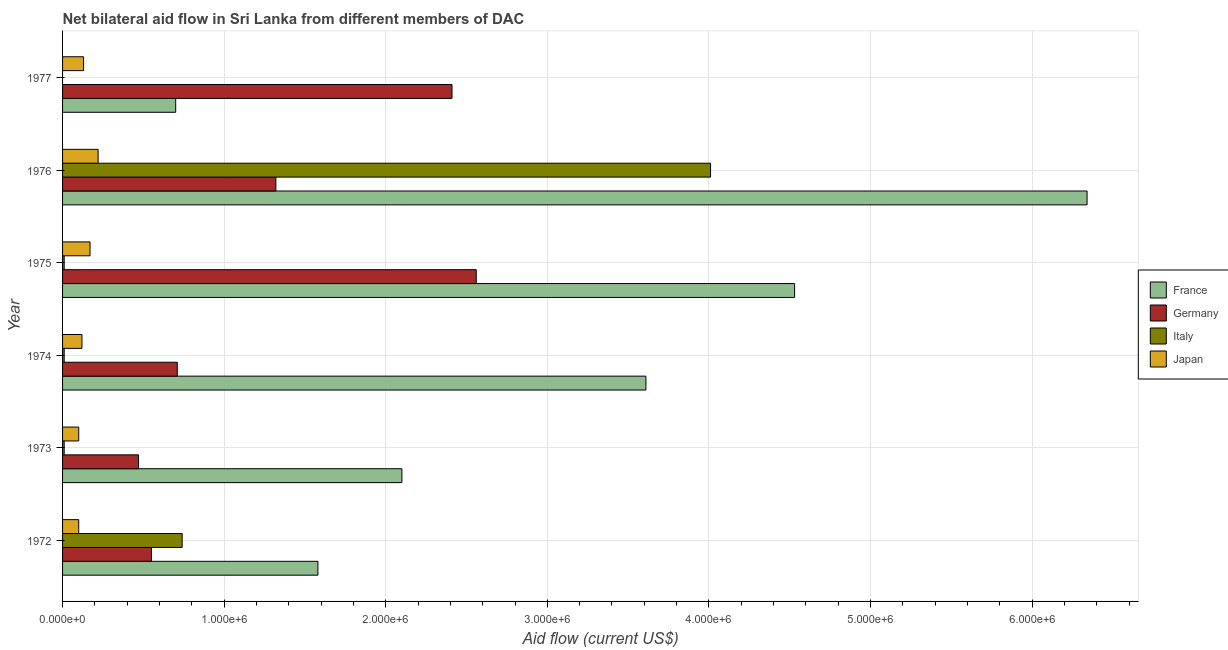How many groups of bars are there?
Your answer should be very brief. 6. Are the number of bars per tick equal to the number of legend labels?
Provide a short and direct response. No. How many bars are there on the 6th tick from the top?
Your answer should be compact. 4. How many bars are there on the 2nd tick from the bottom?
Keep it short and to the point. 4. In how many cases, is the number of bars for a given year not equal to the number of legend labels?
Give a very brief answer. 1. What is the amount of aid given by italy in 1975?
Make the answer very short. 10000. Across all years, what is the maximum amount of aid given by japan?
Provide a short and direct response. 2.20e+05. Across all years, what is the minimum amount of aid given by france?
Offer a very short reply. 7.00e+05. In which year was the amount of aid given by italy maximum?
Offer a very short reply. 1976. What is the total amount of aid given by japan in the graph?
Your response must be concise. 8.40e+05. What is the difference between the amount of aid given by france in 1972 and that in 1975?
Make the answer very short. -2.95e+06. What is the difference between the amount of aid given by italy in 1972 and the amount of aid given by germany in 1976?
Keep it short and to the point. -5.80e+05. What is the average amount of aid given by france per year?
Your response must be concise. 3.14e+06. In the year 1977, what is the difference between the amount of aid given by germany and amount of aid given by japan?
Provide a succinct answer. 2.28e+06. In how many years, is the amount of aid given by france greater than 6200000 US$?
Offer a terse response. 1. What is the ratio of the amount of aid given by japan in 1973 to that in 1976?
Ensure brevity in your answer.  0.46. What is the difference between the highest and the lowest amount of aid given by france?
Ensure brevity in your answer.  5.64e+06. Is the sum of the amount of aid given by france in 1974 and 1976 greater than the maximum amount of aid given by japan across all years?
Ensure brevity in your answer.  Yes. Is it the case that in every year, the sum of the amount of aid given by france and amount of aid given by germany is greater than the amount of aid given by italy?
Provide a succinct answer. Yes. How many bars are there?
Your answer should be compact. 23. Are all the bars in the graph horizontal?
Offer a very short reply. Yes. How many years are there in the graph?
Your answer should be very brief. 6. Are the values on the major ticks of X-axis written in scientific E-notation?
Offer a terse response. Yes. Does the graph contain any zero values?
Provide a succinct answer. Yes. Does the graph contain grids?
Make the answer very short. Yes. What is the title of the graph?
Your response must be concise. Net bilateral aid flow in Sri Lanka from different members of DAC. What is the label or title of the X-axis?
Give a very brief answer. Aid flow (current US$). What is the label or title of the Y-axis?
Your answer should be very brief. Year. What is the Aid flow (current US$) of France in 1972?
Your answer should be compact. 1.58e+06. What is the Aid flow (current US$) of Germany in 1972?
Keep it short and to the point. 5.50e+05. What is the Aid flow (current US$) in Italy in 1972?
Your response must be concise. 7.40e+05. What is the Aid flow (current US$) in France in 1973?
Your answer should be very brief. 2.10e+06. What is the Aid flow (current US$) in France in 1974?
Your answer should be compact. 3.61e+06. What is the Aid flow (current US$) in Germany in 1974?
Provide a short and direct response. 7.10e+05. What is the Aid flow (current US$) in Italy in 1974?
Your answer should be very brief. 10000. What is the Aid flow (current US$) of France in 1975?
Make the answer very short. 4.53e+06. What is the Aid flow (current US$) in Germany in 1975?
Provide a succinct answer. 2.56e+06. What is the Aid flow (current US$) in France in 1976?
Your answer should be compact. 6.34e+06. What is the Aid flow (current US$) in Germany in 1976?
Ensure brevity in your answer.  1.32e+06. What is the Aid flow (current US$) in Italy in 1976?
Offer a very short reply. 4.01e+06. What is the Aid flow (current US$) of Japan in 1976?
Your response must be concise. 2.20e+05. What is the Aid flow (current US$) of France in 1977?
Ensure brevity in your answer.  7.00e+05. What is the Aid flow (current US$) in Germany in 1977?
Make the answer very short. 2.41e+06. What is the Aid flow (current US$) of Japan in 1977?
Keep it short and to the point. 1.30e+05. Across all years, what is the maximum Aid flow (current US$) in France?
Give a very brief answer. 6.34e+06. Across all years, what is the maximum Aid flow (current US$) in Germany?
Keep it short and to the point. 2.56e+06. Across all years, what is the maximum Aid flow (current US$) in Italy?
Give a very brief answer. 4.01e+06. Across all years, what is the minimum Aid flow (current US$) in France?
Your answer should be very brief. 7.00e+05. Across all years, what is the minimum Aid flow (current US$) of Germany?
Make the answer very short. 4.70e+05. Across all years, what is the minimum Aid flow (current US$) in Japan?
Offer a very short reply. 1.00e+05. What is the total Aid flow (current US$) of France in the graph?
Provide a succinct answer. 1.89e+07. What is the total Aid flow (current US$) in Germany in the graph?
Keep it short and to the point. 8.02e+06. What is the total Aid flow (current US$) in Italy in the graph?
Offer a terse response. 4.78e+06. What is the total Aid flow (current US$) in Japan in the graph?
Your answer should be compact. 8.40e+05. What is the difference between the Aid flow (current US$) of France in 1972 and that in 1973?
Your answer should be compact. -5.20e+05. What is the difference between the Aid flow (current US$) in Italy in 1972 and that in 1973?
Provide a succinct answer. 7.30e+05. What is the difference between the Aid flow (current US$) of Japan in 1972 and that in 1973?
Offer a very short reply. 0. What is the difference between the Aid flow (current US$) in France in 1972 and that in 1974?
Give a very brief answer. -2.03e+06. What is the difference between the Aid flow (current US$) in Italy in 1972 and that in 1974?
Make the answer very short. 7.30e+05. What is the difference between the Aid flow (current US$) of Japan in 1972 and that in 1974?
Offer a terse response. -2.00e+04. What is the difference between the Aid flow (current US$) of France in 1972 and that in 1975?
Keep it short and to the point. -2.95e+06. What is the difference between the Aid flow (current US$) in Germany in 1972 and that in 1975?
Keep it short and to the point. -2.01e+06. What is the difference between the Aid flow (current US$) of Italy in 1972 and that in 1975?
Make the answer very short. 7.30e+05. What is the difference between the Aid flow (current US$) in Japan in 1972 and that in 1975?
Give a very brief answer. -7.00e+04. What is the difference between the Aid flow (current US$) in France in 1972 and that in 1976?
Give a very brief answer. -4.76e+06. What is the difference between the Aid flow (current US$) in Germany in 1972 and that in 1976?
Offer a very short reply. -7.70e+05. What is the difference between the Aid flow (current US$) in Italy in 1972 and that in 1976?
Your answer should be very brief. -3.27e+06. What is the difference between the Aid flow (current US$) in France in 1972 and that in 1977?
Offer a terse response. 8.80e+05. What is the difference between the Aid flow (current US$) in Germany in 1972 and that in 1977?
Give a very brief answer. -1.86e+06. What is the difference between the Aid flow (current US$) in Japan in 1972 and that in 1977?
Offer a terse response. -3.00e+04. What is the difference between the Aid flow (current US$) of France in 1973 and that in 1974?
Your response must be concise. -1.51e+06. What is the difference between the Aid flow (current US$) of France in 1973 and that in 1975?
Give a very brief answer. -2.43e+06. What is the difference between the Aid flow (current US$) of Germany in 1973 and that in 1975?
Your answer should be compact. -2.09e+06. What is the difference between the Aid flow (current US$) in Japan in 1973 and that in 1975?
Keep it short and to the point. -7.00e+04. What is the difference between the Aid flow (current US$) of France in 1973 and that in 1976?
Offer a terse response. -4.24e+06. What is the difference between the Aid flow (current US$) of Germany in 1973 and that in 1976?
Your answer should be very brief. -8.50e+05. What is the difference between the Aid flow (current US$) of Japan in 1973 and that in 1976?
Your answer should be very brief. -1.20e+05. What is the difference between the Aid flow (current US$) of France in 1973 and that in 1977?
Provide a short and direct response. 1.40e+06. What is the difference between the Aid flow (current US$) in Germany in 1973 and that in 1977?
Your answer should be compact. -1.94e+06. What is the difference between the Aid flow (current US$) of Japan in 1973 and that in 1977?
Make the answer very short. -3.00e+04. What is the difference between the Aid flow (current US$) in France in 1974 and that in 1975?
Give a very brief answer. -9.20e+05. What is the difference between the Aid flow (current US$) in Germany in 1974 and that in 1975?
Ensure brevity in your answer.  -1.85e+06. What is the difference between the Aid flow (current US$) in Italy in 1974 and that in 1975?
Provide a succinct answer. 0. What is the difference between the Aid flow (current US$) of Japan in 1974 and that in 1975?
Provide a short and direct response. -5.00e+04. What is the difference between the Aid flow (current US$) in France in 1974 and that in 1976?
Provide a succinct answer. -2.73e+06. What is the difference between the Aid flow (current US$) of Germany in 1974 and that in 1976?
Your answer should be very brief. -6.10e+05. What is the difference between the Aid flow (current US$) in Italy in 1974 and that in 1976?
Your response must be concise. -4.00e+06. What is the difference between the Aid flow (current US$) of Japan in 1974 and that in 1976?
Keep it short and to the point. -1.00e+05. What is the difference between the Aid flow (current US$) of France in 1974 and that in 1977?
Provide a succinct answer. 2.91e+06. What is the difference between the Aid flow (current US$) in Germany in 1974 and that in 1977?
Your response must be concise. -1.70e+06. What is the difference between the Aid flow (current US$) in France in 1975 and that in 1976?
Provide a succinct answer. -1.81e+06. What is the difference between the Aid flow (current US$) in Germany in 1975 and that in 1976?
Your answer should be compact. 1.24e+06. What is the difference between the Aid flow (current US$) of Japan in 1975 and that in 1976?
Offer a very short reply. -5.00e+04. What is the difference between the Aid flow (current US$) of France in 1975 and that in 1977?
Provide a succinct answer. 3.83e+06. What is the difference between the Aid flow (current US$) in Germany in 1975 and that in 1977?
Your response must be concise. 1.50e+05. What is the difference between the Aid flow (current US$) of Japan in 1975 and that in 1977?
Your answer should be compact. 4.00e+04. What is the difference between the Aid flow (current US$) in France in 1976 and that in 1977?
Ensure brevity in your answer.  5.64e+06. What is the difference between the Aid flow (current US$) of Germany in 1976 and that in 1977?
Your answer should be very brief. -1.09e+06. What is the difference between the Aid flow (current US$) in France in 1972 and the Aid flow (current US$) in Germany in 1973?
Your answer should be very brief. 1.11e+06. What is the difference between the Aid flow (current US$) in France in 1972 and the Aid flow (current US$) in Italy in 1973?
Your response must be concise. 1.57e+06. What is the difference between the Aid flow (current US$) of France in 1972 and the Aid flow (current US$) of Japan in 1973?
Provide a short and direct response. 1.48e+06. What is the difference between the Aid flow (current US$) in Germany in 1972 and the Aid flow (current US$) in Italy in 1973?
Provide a short and direct response. 5.40e+05. What is the difference between the Aid flow (current US$) in Germany in 1972 and the Aid flow (current US$) in Japan in 1973?
Your response must be concise. 4.50e+05. What is the difference between the Aid flow (current US$) in Italy in 1972 and the Aid flow (current US$) in Japan in 1973?
Make the answer very short. 6.40e+05. What is the difference between the Aid flow (current US$) of France in 1972 and the Aid flow (current US$) of Germany in 1974?
Give a very brief answer. 8.70e+05. What is the difference between the Aid flow (current US$) in France in 1972 and the Aid flow (current US$) in Italy in 1974?
Provide a succinct answer. 1.57e+06. What is the difference between the Aid flow (current US$) of France in 1972 and the Aid flow (current US$) of Japan in 1974?
Keep it short and to the point. 1.46e+06. What is the difference between the Aid flow (current US$) of Germany in 1972 and the Aid flow (current US$) of Italy in 1974?
Offer a very short reply. 5.40e+05. What is the difference between the Aid flow (current US$) of Germany in 1972 and the Aid flow (current US$) of Japan in 1974?
Keep it short and to the point. 4.30e+05. What is the difference between the Aid flow (current US$) of Italy in 1972 and the Aid flow (current US$) of Japan in 1974?
Offer a very short reply. 6.20e+05. What is the difference between the Aid flow (current US$) in France in 1972 and the Aid flow (current US$) in Germany in 1975?
Ensure brevity in your answer.  -9.80e+05. What is the difference between the Aid flow (current US$) of France in 1972 and the Aid flow (current US$) of Italy in 1975?
Your response must be concise. 1.57e+06. What is the difference between the Aid flow (current US$) in France in 1972 and the Aid flow (current US$) in Japan in 1975?
Your response must be concise. 1.41e+06. What is the difference between the Aid flow (current US$) of Germany in 1972 and the Aid flow (current US$) of Italy in 1975?
Offer a very short reply. 5.40e+05. What is the difference between the Aid flow (current US$) of Germany in 1972 and the Aid flow (current US$) of Japan in 1975?
Offer a very short reply. 3.80e+05. What is the difference between the Aid flow (current US$) in Italy in 1972 and the Aid flow (current US$) in Japan in 1975?
Give a very brief answer. 5.70e+05. What is the difference between the Aid flow (current US$) in France in 1972 and the Aid flow (current US$) in Italy in 1976?
Offer a very short reply. -2.43e+06. What is the difference between the Aid flow (current US$) in France in 1972 and the Aid flow (current US$) in Japan in 1976?
Offer a terse response. 1.36e+06. What is the difference between the Aid flow (current US$) in Germany in 1972 and the Aid flow (current US$) in Italy in 1976?
Your answer should be very brief. -3.46e+06. What is the difference between the Aid flow (current US$) of Germany in 1972 and the Aid flow (current US$) of Japan in 1976?
Ensure brevity in your answer.  3.30e+05. What is the difference between the Aid flow (current US$) of Italy in 1972 and the Aid flow (current US$) of Japan in 1976?
Offer a very short reply. 5.20e+05. What is the difference between the Aid flow (current US$) in France in 1972 and the Aid flow (current US$) in Germany in 1977?
Your answer should be very brief. -8.30e+05. What is the difference between the Aid flow (current US$) of France in 1972 and the Aid flow (current US$) of Japan in 1977?
Make the answer very short. 1.45e+06. What is the difference between the Aid flow (current US$) in Germany in 1972 and the Aid flow (current US$) in Japan in 1977?
Your response must be concise. 4.20e+05. What is the difference between the Aid flow (current US$) of Italy in 1972 and the Aid flow (current US$) of Japan in 1977?
Your response must be concise. 6.10e+05. What is the difference between the Aid flow (current US$) in France in 1973 and the Aid flow (current US$) in Germany in 1974?
Make the answer very short. 1.39e+06. What is the difference between the Aid flow (current US$) in France in 1973 and the Aid flow (current US$) in Italy in 1974?
Ensure brevity in your answer.  2.09e+06. What is the difference between the Aid flow (current US$) of France in 1973 and the Aid flow (current US$) of Japan in 1974?
Provide a short and direct response. 1.98e+06. What is the difference between the Aid flow (current US$) in Germany in 1973 and the Aid flow (current US$) in Italy in 1974?
Offer a terse response. 4.60e+05. What is the difference between the Aid flow (current US$) of France in 1973 and the Aid flow (current US$) of Germany in 1975?
Offer a very short reply. -4.60e+05. What is the difference between the Aid flow (current US$) in France in 1973 and the Aid flow (current US$) in Italy in 1975?
Your answer should be compact. 2.09e+06. What is the difference between the Aid flow (current US$) in France in 1973 and the Aid flow (current US$) in Japan in 1975?
Make the answer very short. 1.93e+06. What is the difference between the Aid flow (current US$) in Germany in 1973 and the Aid flow (current US$) in Japan in 1975?
Keep it short and to the point. 3.00e+05. What is the difference between the Aid flow (current US$) in Italy in 1973 and the Aid flow (current US$) in Japan in 1975?
Your answer should be very brief. -1.60e+05. What is the difference between the Aid flow (current US$) of France in 1973 and the Aid flow (current US$) of Germany in 1976?
Give a very brief answer. 7.80e+05. What is the difference between the Aid flow (current US$) of France in 1973 and the Aid flow (current US$) of Italy in 1976?
Offer a terse response. -1.91e+06. What is the difference between the Aid flow (current US$) in France in 1973 and the Aid flow (current US$) in Japan in 1976?
Your answer should be very brief. 1.88e+06. What is the difference between the Aid flow (current US$) in Germany in 1973 and the Aid flow (current US$) in Italy in 1976?
Provide a succinct answer. -3.54e+06. What is the difference between the Aid flow (current US$) of Italy in 1973 and the Aid flow (current US$) of Japan in 1976?
Keep it short and to the point. -2.10e+05. What is the difference between the Aid flow (current US$) of France in 1973 and the Aid flow (current US$) of Germany in 1977?
Offer a terse response. -3.10e+05. What is the difference between the Aid flow (current US$) of France in 1973 and the Aid flow (current US$) of Japan in 1977?
Offer a very short reply. 1.97e+06. What is the difference between the Aid flow (current US$) in France in 1974 and the Aid flow (current US$) in Germany in 1975?
Provide a succinct answer. 1.05e+06. What is the difference between the Aid flow (current US$) of France in 1974 and the Aid flow (current US$) of Italy in 1975?
Provide a short and direct response. 3.60e+06. What is the difference between the Aid flow (current US$) of France in 1974 and the Aid flow (current US$) of Japan in 1975?
Provide a succinct answer. 3.44e+06. What is the difference between the Aid flow (current US$) in Germany in 1974 and the Aid flow (current US$) in Japan in 1975?
Give a very brief answer. 5.40e+05. What is the difference between the Aid flow (current US$) of France in 1974 and the Aid flow (current US$) of Germany in 1976?
Ensure brevity in your answer.  2.29e+06. What is the difference between the Aid flow (current US$) in France in 1974 and the Aid flow (current US$) in Italy in 1976?
Ensure brevity in your answer.  -4.00e+05. What is the difference between the Aid flow (current US$) in France in 1974 and the Aid flow (current US$) in Japan in 1976?
Keep it short and to the point. 3.39e+06. What is the difference between the Aid flow (current US$) in Germany in 1974 and the Aid flow (current US$) in Italy in 1976?
Your answer should be compact. -3.30e+06. What is the difference between the Aid flow (current US$) of Germany in 1974 and the Aid flow (current US$) of Japan in 1976?
Make the answer very short. 4.90e+05. What is the difference between the Aid flow (current US$) of France in 1974 and the Aid flow (current US$) of Germany in 1977?
Your answer should be very brief. 1.20e+06. What is the difference between the Aid flow (current US$) in France in 1974 and the Aid flow (current US$) in Japan in 1977?
Ensure brevity in your answer.  3.48e+06. What is the difference between the Aid flow (current US$) of Germany in 1974 and the Aid flow (current US$) of Japan in 1977?
Your answer should be compact. 5.80e+05. What is the difference between the Aid flow (current US$) of Italy in 1974 and the Aid flow (current US$) of Japan in 1977?
Keep it short and to the point. -1.20e+05. What is the difference between the Aid flow (current US$) in France in 1975 and the Aid flow (current US$) in Germany in 1976?
Your answer should be compact. 3.21e+06. What is the difference between the Aid flow (current US$) of France in 1975 and the Aid flow (current US$) of Italy in 1976?
Offer a very short reply. 5.20e+05. What is the difference between the Aid flow (current US$) in France in 1975 and the Aid flow (current US$) in Japan in 1976?
Make the answer very short. 4.31e+06. What is the difference between the Aid flow (current US$) of Germany in 1975 and the Aid flow (current US$) of Italy in 1976?
Your response must be concise. -1.45e+06. What is the difference between the Aid flow (current US$) in Germany in 1975 and the Aid flow (current US$) in Japan in 1976?
Provide a short and direct response. 2.34e+06. What is the difference between the Aid flow (current US$) in Italy in 1975 and the Aid flow (current US$) in Japan in 1976?
Make the answer very short. -2.10e+05. What is the difference between the Aid flow (current US$) in France in 1975 and the Aid flow (current US$) in Germany in 1977?
Keep it short and to the point. 2.12e+06. What is the difference between the Aid flow (current US$) in France in 1975 and the Aid flow (current US$) in Japan in 1977?
Provide a short and direct response. 4.40e+06. What is the difference between the Aid flow (current US$) in Germany in 1975 and the Aid flow (current US$) in Japan in 1977?
Offer a terse response. 2.43e+06. What is the difference between the Aid flow (current US$) in Italy in 1975 and the Aid flow (current US$) in Japan in 1977?
Offer a terse response. -1.20e+05. What is the difference between the Aid flow (current US$) in France in 1976 and the Aid flow (current US$) in Germany in 1977?
Your answer should be very brief. 3.93e+06. What is the difference between the Aid flow (current US$) in France in 1976 and the Aid flow (current US$) in Japan in 1977?
Offer a terse response. 6.21e+06. What is the difference between the Aid flow (current US$) in Germany in 1976 and the Aid flow (current US$) in Japan in 1977?
Give a very brief answer. 1.19e+06. What is the difference between the Aid flow (current US$) of Italy in 1976 and the Aid flow (current US$) of Japan in 1977?
Your response must be concise. 3.88e+06. What is the average Aid flow (current US$) of France per year?
Provide a short and direct response. 3.14e+06. What is the average Aid flow (current US$) in Germany per year?
Offer a terse response. 1.34e+06. What is the average Aid flow (current US$) of Italy per year?
Provide a succinct answer. 7.97e+05. In the year 1972, what is the difference between the Aid flow (current US$) of France and Aid flow (current US$) of Germany?
Ensure brevity in your answer.  1.03e+06. In the year 1972, what is the difference between the Aid flow (current US$) of France and Aid flow (current US$) of Italy?
Provide a succinct answer. 8.40e+05. In the year 1972, what is the difference between the Aid flow (current US$) in France and Aid flow (current US$) in Japan?
Provide a succinct answer. 1.48e+06. In the year 1972, what is the difference between the Aid flow (current US$) in Germany and Aid flow (current US$) in Italy?
Your answer should be very brief. -1.90e+05. In the year 1972, what is the difference between the Aid flow (current US$) of Germany and Aid flow (current US$) of Japan?
Provide a succinct answer. 4.50e+05. In the year 1972, what is the difference between the Aid flow (current US$) in Italy and Aid flow (current US$) in Japan?
Offer a terse response. 6.40e+05. In the year 1973, what is the difference between the Aid flow (current US$) in France and Aid flow (current US$) in Germany?
Your answer should be very brief. 1.63e+06. In the year 1973, what is the difference between the Aid flow (current US$) of France and Aid flow (current US$) of Italy?
Your response must be concise. 2.09e+06. In the year 1974, what is the difference between the Aid flow (current US$) in France and Aid flow (current US$) in Germany?
Your answer should be very brief. 2.90e+06. In the year 1974, what is the difference between the Aid flow (current US$) in France and Aid flow (current US$) in Italy?
Give a very brief answer. 3.60e+06. In the year 1974, what is the difference between the Aid flow (current US$) of France and Aid flow (current US$) of Japan?
Ensure brevity in your answer.  3.49e+06. In the year 1974, what is the difference between the Aid flow (current US$) of Germany and Aid flow (current US$) of Japan?
Provide a succinct answer. 5.90e+05. In the year 1974, what is the difference between the Aid flow (current US$) in Italy and Aid flow (current US$) in Japan?
Provide a short and direct response. -1.10e+05. In the year 1975, what is the difference between the Aid flow (current US$) of France and Aid flow (current US$) of Germany?
Your answer should be compact. 1.97e+06. In the year 1975, what is the difference between the Aid flow (current US$) in France and Aid flow (current US$) in Italy?
Ensure brevity in your answer.  4.52e+06. In the year 1975, what is the difference between the Aid flow (current US$) in France and Aid flow (current US$) in Japan?
Provide a short and direct response. 4.36e+06. In the year 1975, what is the difference between the Aid flow (current US$) of Germany and Aid flow (current US$) of Italy?
Offer a very short reply. 2.55e+06. In the year 1975, what is the difference between the Aid flow (current US$) of Germany and Aid flow (current US$) of Japan?
Make the answer very short. 2.39e+06. In the year 1975, what is the difference between the Aid flow (current US$) in Italy and Aid flow (current US$) in Japan?
Provide a short and direct response. -1.60e+05. In the year 1976, what is the difference between the Aid flow (current US$) in France and Aid flow (current US$) in Germany?
Offer a terse response. 5.02e+06. In the year 1976, what is the difference between the Aid flow (current US$) of France and Aid flow (current US$) of Italy?
Your response must be concise. 2.33e+06. In the year 1976, what is the difference between the Aid flow (current US$) in France and Aid flow (current US$) in Japan?
Provide a short and direct response. 6.12e+06. In the year 1976, what is the difference between the Aid flow (current US$) of Germany and Aid flow (current US$) of Italy?
Provide a succinct answer. -2.69e+06. In the year 1976, what is the difference between the Aid flow (current US$) of Germany and Aid flow (current US$) of Japan?
Ensure brevity in your answer.  1.10e+06. In the year 1976, what is the difference between the Aid flow (current US$) in Italy and Aid flow (current US$) in Japan?
Provide a short and direct response. 3.79e+06. In the year 1977, what is the difference between the Aid flow (current US$) of France and Aid flow (current US$) of Germany?
Provide a short and direct response. -1.71e+06. In the year 1977, what is the difference between the Aid flow (current US$) in France and Aid flow (current US$) in Japan?
Provide a short and direct response. 5.70e+05. In the year 1977, what is the difference between the Aid flow (current US$) in Germany and Aid flow (current US$) in Japan?
Your answer should be very brief. 2.28e+06. What is the ratio of the Aid flow (current US$) in France in 1972 to that in 1973?
Your response must be concise. 0.75. What is the ratio of the Aid flow (current US$) in Germany in 1972 to that in 1973?
Offer a very short reply. 1.17. What is the ratio of the Aid flow (current US$) of France in 1972 to that in 1974?
Offer a terse response. 0.44. What is the ratio of the Aid flow (current US$) of Germany in 1972 to that in 1974?
Keep it short and to the point. 0.77. What is the ratio of the Aid flow (current US$) of Italy in 1972 to that in 1974?
Give a very brief answer. 74. What is the ratio of the Aid flow (current US$) of Japan in 1972 to that in 1974?
Ensure brevity in your answer.  0.83. What is the ratio of the Aid flow (current US$) in France in 1972 to that in 1975?
Offer a terse response. 0.35. What is the ratio of the Aid flow (current US$) of Germany in 1972 to that in 1975?
Provide a succinct answer. 0.21. What is the ratio of the Aid flow (current US$) in Japan in 1972 to that in 1975?
Your answer should be compact. 0.59. What is the ratio of the Aid flow (current US$) of France in 1972 to that in 1976?
Offer a very short reply. 0.25. What is the ratio of the Aid flow (current US$) of Germany in 1972 to that in 1976?
Your response must be concise. 0.42. What is the ratio of the Aid flow (current US$) of Italy in 1972 to that in 1976?
Provide a succinct answer. 0.18. What is the ratio of the Aid flow (current US$) of Japan in 1972 to that in 1976?
Offer a very short reply. 0.45. What is the ratio of the Aid flow (current US$) of France in 1972 to that in 1977?
Your answer should be compact. 2.26. What is the ratio of the Aid flow (current US$) of Germany in 1972 to that in 1977?
Keep it short and to the point. 0.23. What is the ratio of the Aid flow (current US$) in Japan in 1972 to that in 1977?
Provide a succinct answer. 0.77. What is the ratio of the Aid flow (current US$) of France in 1973 to that in 1974?
Keep it short and to the point. 0.58. What is the ratio of the Aid flow (current US$) in Germany in 1973 to that in 1974?
Make the answer very short. 0.66. What is the ratio of the Aid flow (current US$) of Japan in 1973 to that in 1974?
Your answer should be very brief. 0.83. What is the ratio of the Aid flow (current US$) of France in 1973 to that in 1975?
Offer a terse response. 0.46. What is the ratio of the Aid flow (current US$) in Germany in 1973 to that in 1975?
Provide a short and direct response. 0.18. What is the ratio of the Aid flow (current US$) of Japan in 1973 to that in 1975?
Provide a short and direct response. 0.59. What is the ratio of the Aid flow (current US$) of France in 1973 to that in 1976?
Offer a very short reply. 0.33. What is the ratio of the Aid flow (current US$) in Germany in 1973 to that in 1976?
Offer a very short reply. 0.36. What is the ratio of the Aid flow (current US$) in Italy in 1973 to that in 1976?
Keep it short and to the point. 0. What is the ratio of the Aid flow (current US$) in Japan in 1973 to that in 1976?
Offer a terse response. 0.45. What is the ratio of the Aid flow (current US$) in Germany in 1973 to that in 1977?
Your response must be concise. 0.2. What is the ratio of the Aid flow (current US$) of Japan in 1973 to that in 1977?
Offer a very short reply. 0.77. What is the ratio of the Aid flow (current US$) of France in 1974 to that in 1975?
Make the answer very short. 0.8. What is the ratio of the Aid flow (current US$) in Germany in 1974 to that in 1975?
Provide a short and direct response. 0.28. What is the ratio of the Aid flow (current US$) in Italy in 1974 to that in 1975?
Keep it short and to the point. 1. What is the ratio of the Aid flow (current US$) in Japan in 1974 to that in 1975?
Offer a very short reply. 0.71. What is the ratio of the Aid flow (current US$) in France in 1974 to that in 1976?
Provide a short and direct response. 0.57. What is the ratio of the Aid flow (current US$) in Germany in 1974 to that in 1976?
Your answer should be very brief. 0.54. What is the ratio of the Aid flow (current US$) in Italy in 1974 to that in 1976?
Make the answer very short. 0. What is the ratio of the Aid flow (current US$) in Japan in 1974 to that in 1976?
Keep it short and to the point. 0.55. What is the ratio of the Aid flow (current US$) of France in 1974 to that in 1977?
Keep it short and to the point. 5.16. What is the ratio of the Aid flow (current US$) of Germany in 1974 to that in 1977?
Your answer should be very brief. 0.29. What is the ratio of the Aid flow (current US$) of Japan in 1974 to that in 1977?
Provide a succinct answer. 0.92. What is the ratio of the Aid flow (current US$) in France in 1975 to that in 1976?
Your answer should be very brief. 0.71. What is the ratio of the Aid flow (current US$) of Germany in 1975 to that in 1976?
Give a very brief answer. 1.94. What is the ratio of the Aid flow (current US$) in Italy in 1975 to that in 1976?
Offer a terse response. 0. What is the ratio of the Aid flow (current US$) of Japan in 1975 to that in 1976?
Give a very brief answer. 0.77. What is the ratio of the Aid flow (current US$) of France in 1975 to that in 1977?
Keep it short and to the point. 6.47. What is the ratio of the Aid flow (current US$) of Germany in 1975 to that in 1977?
Offer a very short reply. 1.06. What is the ratio of the Aid flow (current US$) in Japan in 1975 to that in 1977?
Offer a very short reply. 1.31. What is the ratio of the Aid flow (current US$) of France in 1976 to that in 1977?
Offer a very short reply. 9.06. What is the ratio of the Aid flow (current US$) of Germany in 1976 to that in 1977?
Provide a succinct answer. 0.55. What is the ratio of the Aid flow (current US$) of Japan in 1976 to that in 1977?
Provide a short and direct response. 1.69. What is the difference between the highest and the second highest Aid flow (current US$) of France?
Offer a terse response. 1.81e+06. What is the difference between the highest and the second highest Aid flow (current US$) of Italy?
Ensure brevity in your answer.  3.27e+06. What is the difference between the highest and the lowest Aid flow (current US$) of France?
Ensure brevity in your answer.  5.64e+06. What is the difference between the highest and the lowest Aid flow (current US$) in Germany?
Your answer should be compact. 2.09e+06. What is the difference between the highest and the lowest Aid flow (current US$) of Italy?
Offer a terse response. 4.01e+06. 